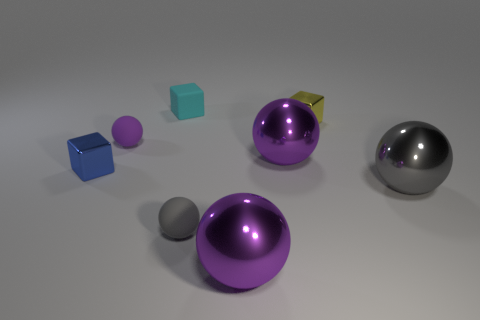Subtract all green cylinders. How many purple spheres are left? 3 Subtract all small purple spheres. How many spheres are left? 4 Subtract all blue balls. Subtract all purple cubes. How many balls are left? 5 Add 1 blocks. How many objects exist? 9 Subtract all blocks. How many objects are left? 5 Add 6 tiny red shiny things. How many tiny red shiny things exist? 6 Subtract 0 blue cylinders. How many objects are left? 8 Subtract all large objects. Subtract all metal cubes. How many objects are left? 3 Add 4 big purple metallic balls. How many big purple metallic balls are left? 6 